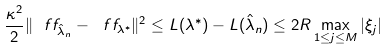<formula> <loc_0><loc_0><loc_500><loc_500>\frac { \kappa ^ { 2 } } { 2 } \| \ f f _ { \hat { \lambda } _ { n } } - \ f f _ { \lambda ^ { * } } \| ^ { 2 } \leq L ( { \lambda ^ { * } } ) - L ( { \hat { \lambda } _ { n } } ) \leq 2 R \max _ { 1 \leq j \leq M } | \xi _ { j } | \,</formula> 